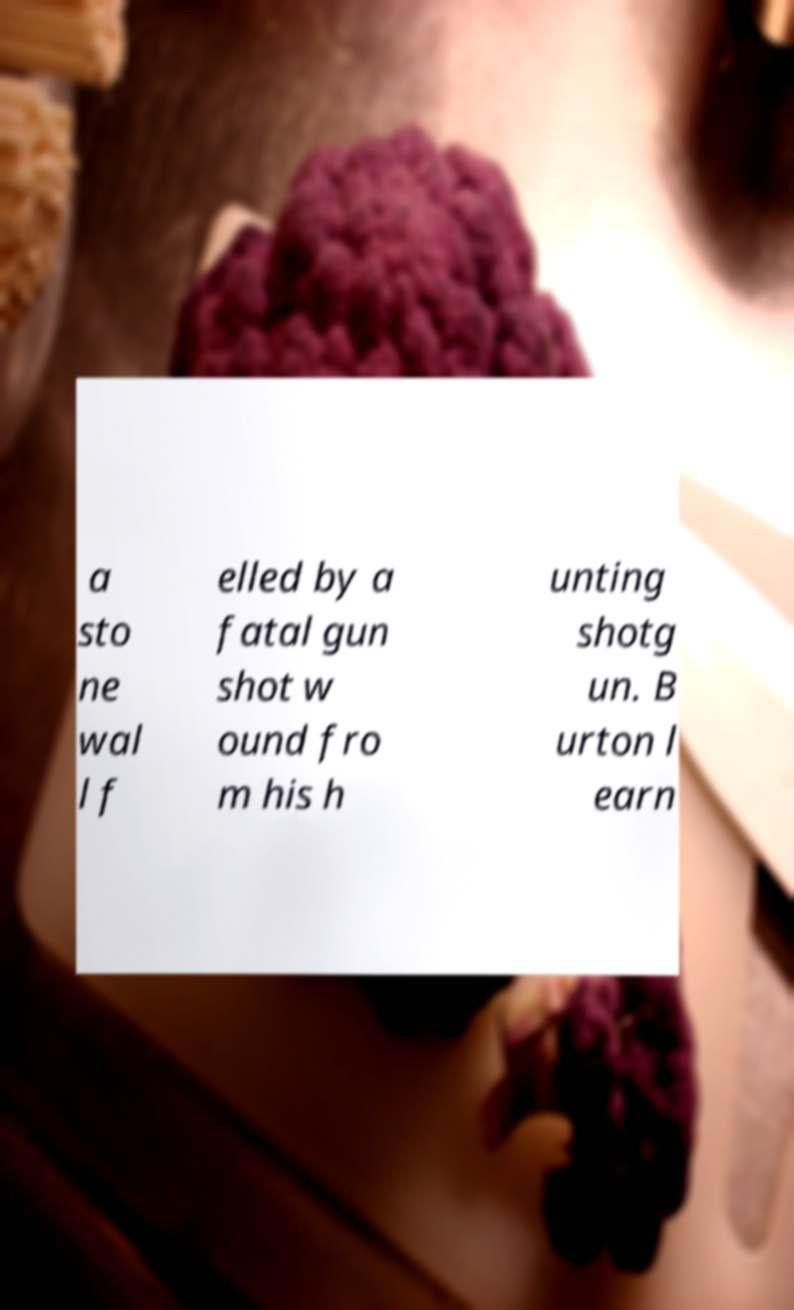Please read and relay the text visible in this image. What does it say? a sto ne wal l f elled by a fatal gun shot w ound fro m his h unting shotg un. B urton l earn 